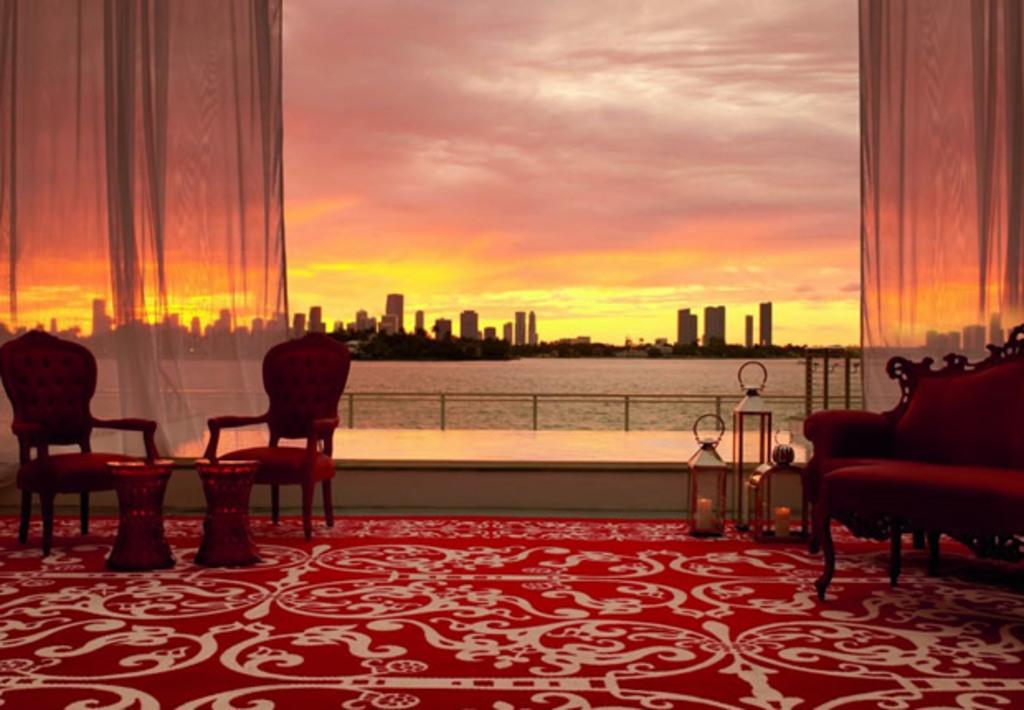Describe this image in one or two sentences. This is the picture taken in a room, in this room there are chairs, table and sofa. Background of this chair is a water, building and sky. 